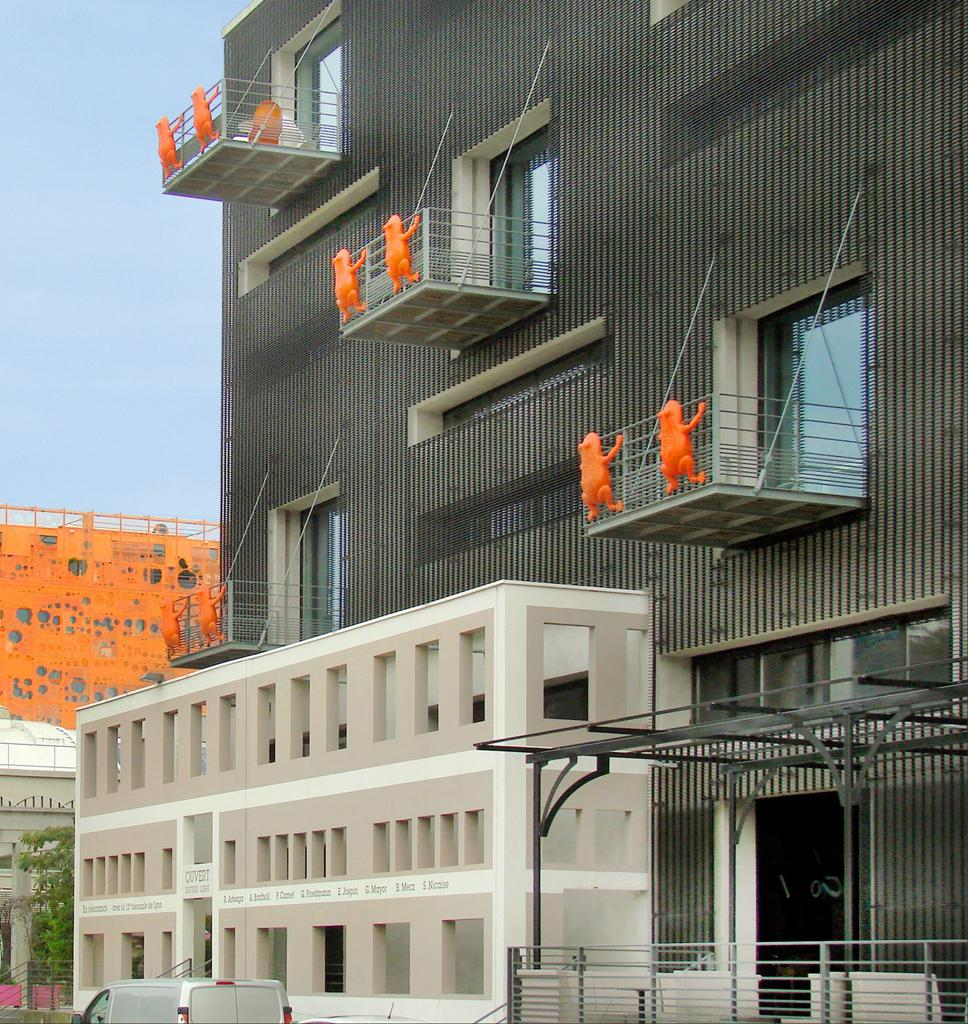What type of structures can be seen in the image? There are buildings in the image. What other natural elements are present in the image? There are trees in the image. Is there any transportation visible in the image? Yes, there is a parked vehicle in the image. What is visible at the top of the image? The sky is visible at the top of the image and appears to be clear. What type of minister is conducting a meeting in the image? There is no minister or meeting present in the image. How does the roll of paper fit into the image? There is no roll of paper mentioned in the provided facts, so it cannot be determined how it would fit into the image. 